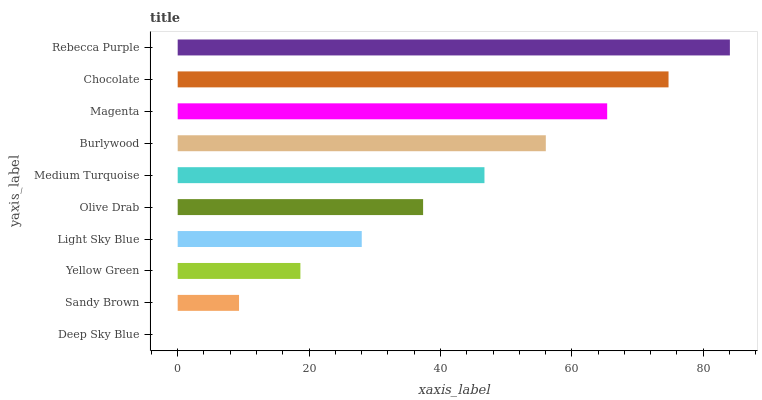Is Deep Sky Blue the minimum?
Answer yes or no. Yes. Is Rebecca Purple the maximum?
Answer yes or no. Yes. Is Sandy Brown the minimum?
Answer yes or no. No. Is Sandy Brown the maximum?
Answer yes or no. No. Is Sandy Brown greater than Deep Sky Blue?
Answer yes or no. Yes. Is Deep Sky Blue less than Sandy Brown?
Answer yes or no. Yes. Is Deep Sky Blue greater than Sandy Brown?
Answer yes or no. No. Is Sandy Brown less than Deep Sky Blue?
Answer yes or no. No. Is Medium Turquoise the high median?
Answer yes or no. Yes. Is Olive Drab the low median?
Answer yes or no. Yes. Is Magenta the high median?
Answer yes or no. No. Is Burlywood the low median?
Answer yes or no. No. 